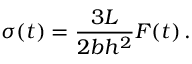<formula> <loc_0><loc_0><loc_500><loc_500>\sigma ( t ) = \frac { 3 L } { 2 b h ^ { 2 } } F ( t ) \, .</formula> 